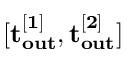Convert formula to latex. <formula><loc_0><loc_0><loc_500><loc_500>[ t _ { o u t } ^ { [ 1 ] } , t _ { o u t } ^ { [ 2 ] } ]</formula> 